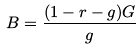<formula> <loc_0><loc_0><loc_500><loc_500>B = \frac { ( 1 - r - g ) G } { g }</formula> 